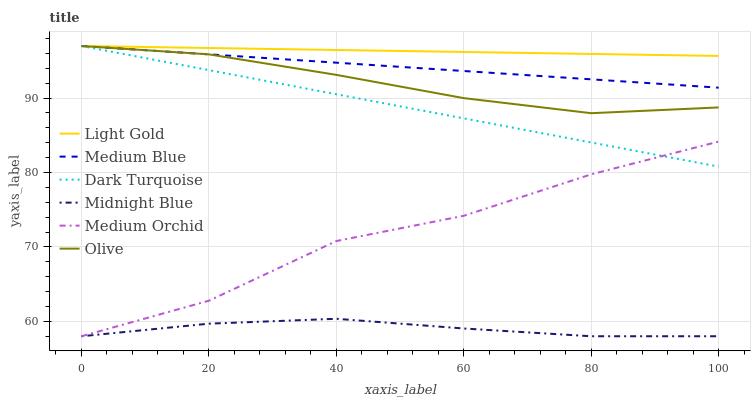Does Midnight Blue have the minimum area under the curve?
Answer yes or no. Yes. Does Light Gold have the maximum area under the curve?
Answer yes or no. Yes. Does Dark Turquoise have the minimum area under the curve?
Answer yes or no. No. Does Dark Turquoise have the maximum area under the curve?
Answer yes or no. No. Is Dark Turquoise the smoothest?
Answer yes or no. Yes. Is Medium Orchid the roughest?
Answer yes or no. Yes. Is Medium Orchid the smoothest?
Answer yes or no. No. Is Dark Turquoise the roughest?
Answer yes or no. No. Does Midnight Blue have the lowest value?
Answer yes or no. Yes. Does Dark Turquoise have the lowest value?
Answer yes or no. No. Does Light Gold have the highest value?
Answer yes or no. Yes. Does Medium Orchid have the highest value?
Answer yes or no. No. Is Midnight Blue less than Olive?
Answer yes or no. Yes. Is Medium Blue greater than Medium Orchid?
Answer yes or no. Yes. Does Olive intersect Light Gold?
Answer yes or no. Yes. Is Olive less than Light Gold?
Answer yes or no. No. Is Olive greater than Light Gold?
Answer yes or no. No. Does Midnight Blue intersect Olive?
Answer yes or no. No. 